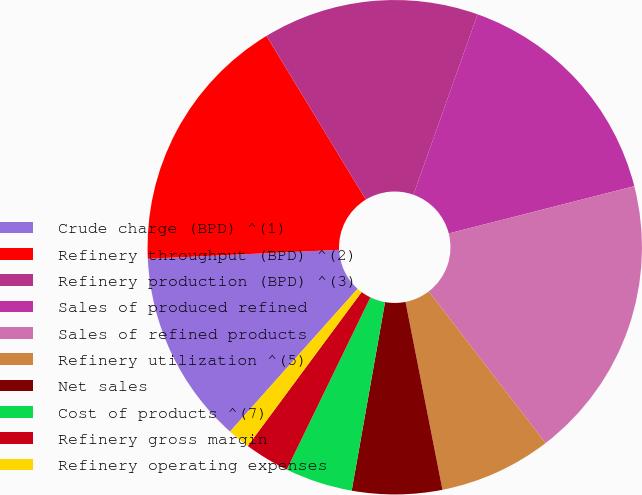Convert chart to OTSL. <chart><loc_0><loc_0><loc_500><loc_500><pie_chart><fcel>Crude charge (BPD) ^(1)<fcel>Refinery throughput (BPD) ^(2)<fcel>Refinery production (BPD) ^(3)<fcel>Sales of produced refined<fcel>Sales of refined products<fcel>Refinery utilization ^(5)<fcel>Net sales<fcel>Cost of products ^(7)<fcel>Refinery gross margin<fcel>Refinery operating expenses<nl><fcel>12.65%<fcel>17.06%<fcel>14.12%<fcel>15.59%<fcel>18.53%<fcel>7.35%<fcel>5.88%<fcel>4.41%<fcel>2.94%<fcel>1.47%<nl></chart> 